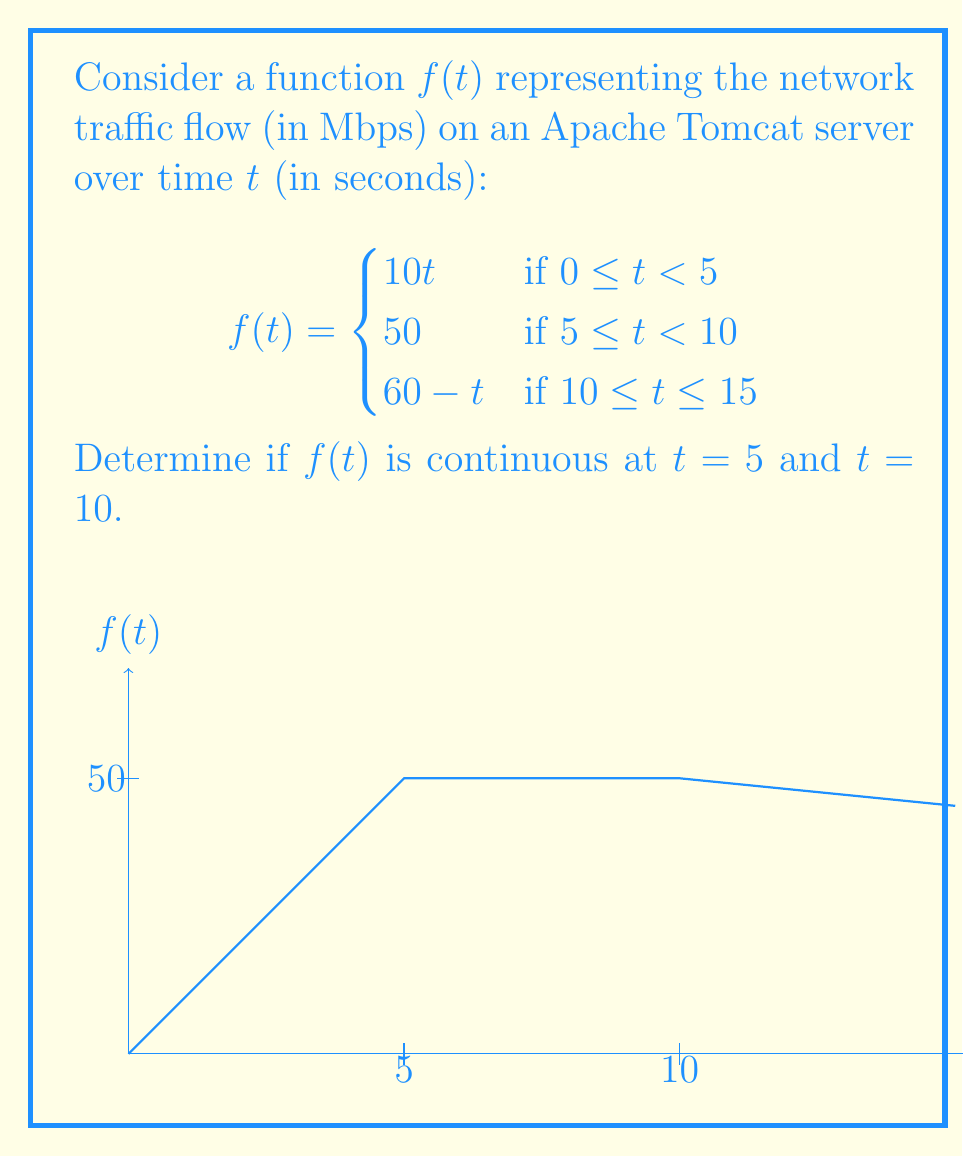Give your solution to this math problem. To determine the continuity of $f(t)$ at $t = 5$ and $t = 10$, we need to check if the function satisfies the three conditions for continuity at these points:

1. The function is defined at the point
2. The limit of the function as we approach the point from both sides exists
3. The limit equals the function value at that point

For $t = 5$:

1. $f(5)$ is defined: $f(5) = 50$
2. Left-hand limit: $\lim_{t \to 5^-} f(t) = \lim_{t \to 5^-} 10t = 50$
   Right-hand limit: $\lim_{t \to 5^+} f(t) = 50$
3. $\lim_{t \to 5} f(t) = f(5) = 50$

All three conditions are satisfied, so $f(t)$ is continuous at $t = 5$.

For $t = 10$:

1. $f(10)$ is defined: $f(10) = 50$
2. Left-hand limit: $\lim_{t \to 10^-} f(t) = 50$
   Right-hand limit: $\lim_{t \to 10^+} f(t) = \lim_{t \to 10^+} (60 - t) = 50$
3. $\lim_{t \to 10} f(t) = f(10) = 50$

All three conditions are satisfied, so $f(t)$ is continuous at $t = 10$.
Answer: $f(t)$ is continuous at both $t = 5$ and $t = 10$. 